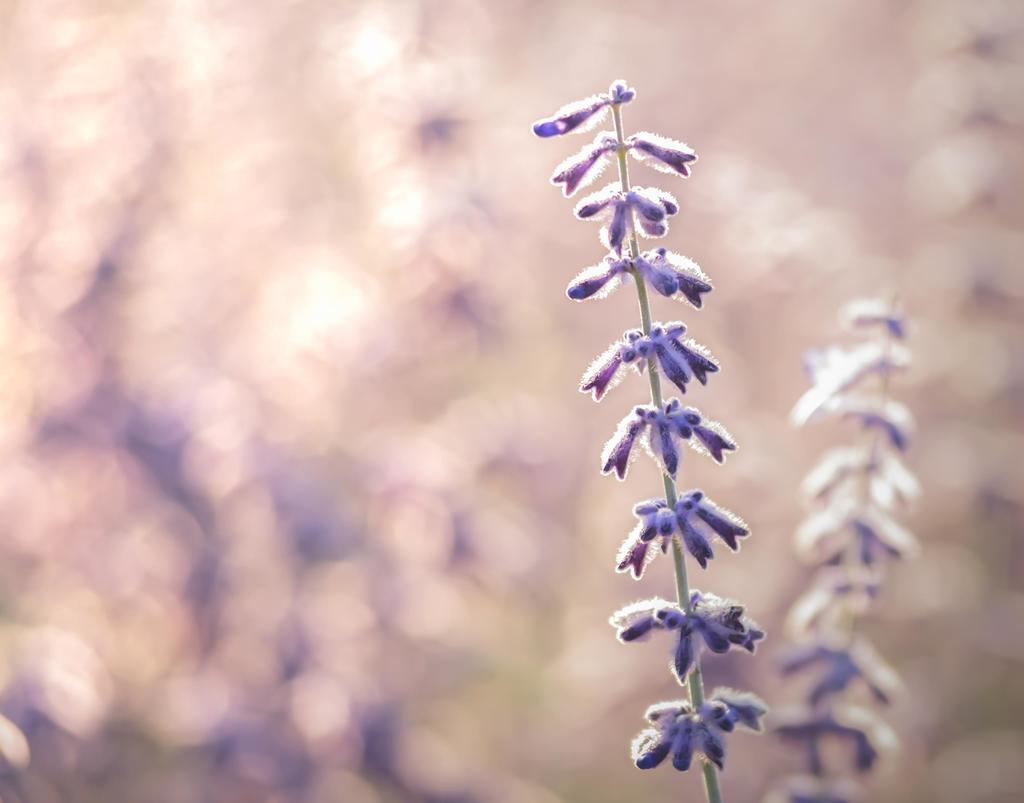What is present in the image? There is a plant in the image. What specific feature of the plant can be observed? The plant has flowers. What color are the flowers? The flowers are violet in color. Can you describe the background of the image? The background of the image is blurred. What type of roll is being performed by the plant in the image? There is no roll being performed by the plant in the image, as plants do not have the ability to perform rolls. 